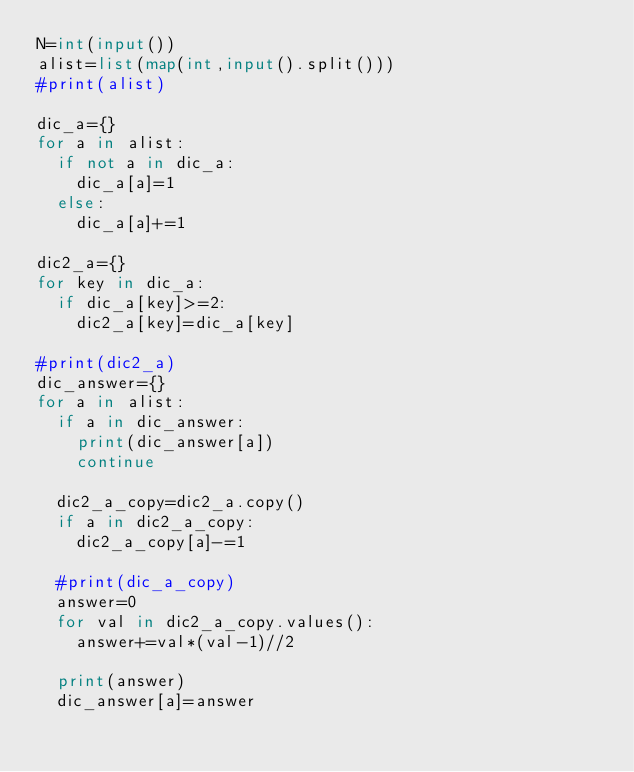<code> <loc_0><loc_0><loc_500><loc_500><_Python_>N=int(input())
alist=list(map(int,input().split()))
#print(alist)

dic_a={}
for a in alist:
  if not a in dic_a:
    dic_a[a]=1
  else:
    dic_a[a]+=1
    
dic2_a={}
for key in dic_a:
  if dic_a[key]>=2:
    dic2_a[key]=dic_a[key]
    
#print(dic2_a)
dic_answer={}
for a in alist:
  if a in dic_answer:
    print(dic_answer[a])
    continue
  
  dic2_a_copy=dic2_a.copy()
  if a in dic2_a_copy:
    dic2_a_copy[a]-=1
  
  #print(dic_a_copy)
  answer=0
  for val in dic2_a_copy.values():
    answer+=val*(val-1)//2
    
  print(answer)
  dic_answer[a]=answer</code> 